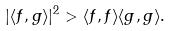<formula> <loc_0><loc_0><loc_500><loc_500>| \langle f , g \rangle | ^ { 2 } > \langle f , f \rangle \langle g , g \rangle .</formula> 